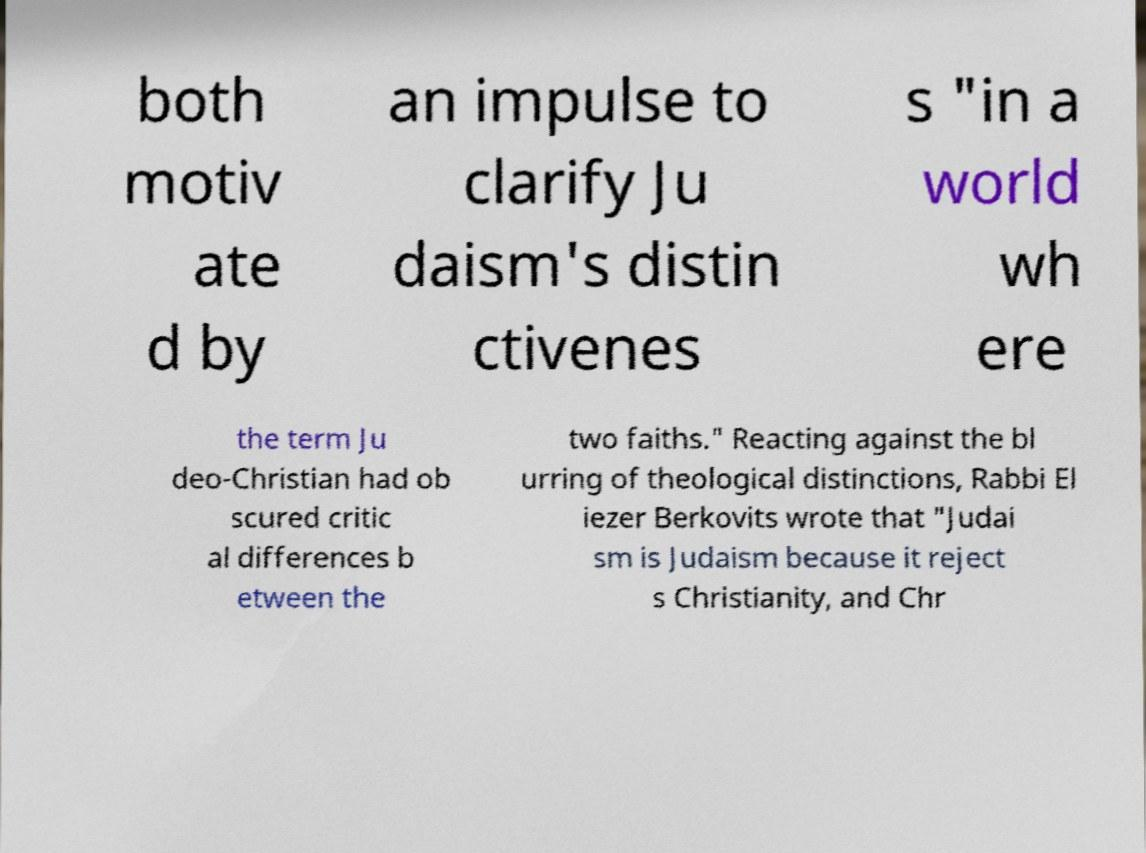Please read and relay the text visible in this image. What does it say? both motiv ate d by an impulse to clarify Ju daism's distin ctivenes s "in a world wh ere the term Ju deo-Christian had ob scured critic al differences b etween the two faiths." Reacting against the bl urring of theological distinctions, Rabbi El iezer Berkovits wrote that "Judai sm is Judaism because it reject s Christianity, and Chr 